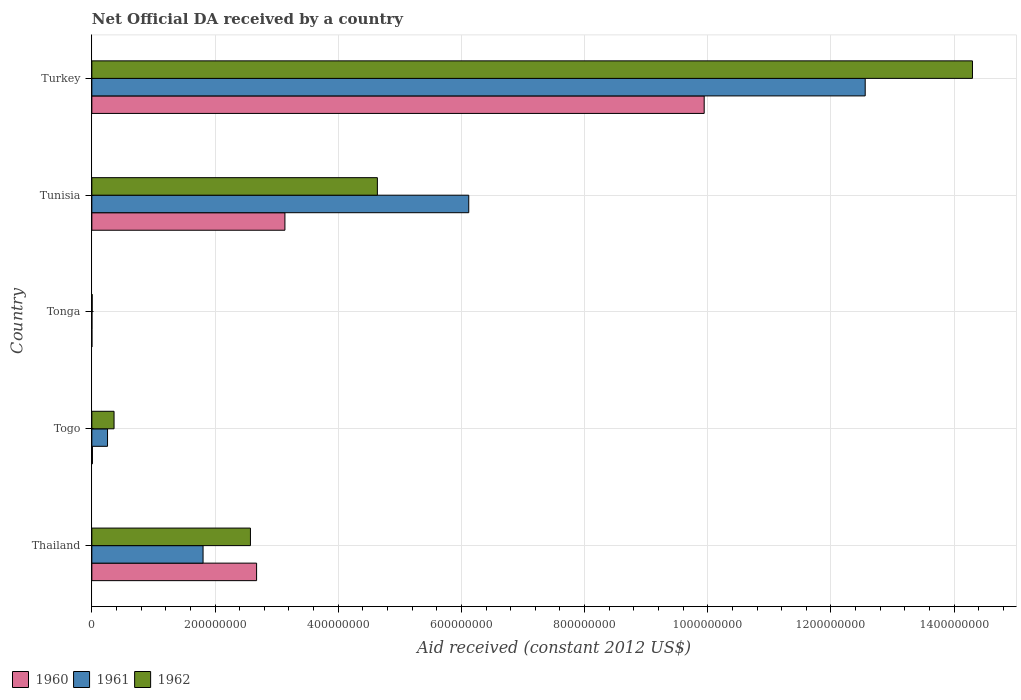How many different coloured bars are there?
Keep it short and to the point. 3. How many groups of bars are there?
Provide a succinct answer. 5. Are the number of bars on each tick of the Y-axis equal?
Make the answer very short. Yes. How many bars are there on the 1st tick from the top?
Provide a short and direct response. 3. How many bars are there on the 3rd tick from the bottom?
Give a very brief answer. 3. What is the label of the 2nd group of bars from the top?
Give a very brief answer. Tunisia. In how many cases, is the number of bars for a given country not equal to the number of legend labels?
Your answer should be compact. 0. Across all countries, what is the maximum net official development assistance aid received in 1961?
Offer a terse response. 1.26e+09. Across all countries, what is the minimum net official development assistance aid received in 1960?
Provide a succinct answer. 8.00e+04. In which country was the net official development assistance aid received in 1960 minimum?
Offer a terse response. Tonga. What is the total net official development assistance aid received in 1960 in the graph?
Your answer should be compact. 1.58e+09. What is the difference between the net official development assistance aid received in 1961 in Tonga and that in Tunisia?
Your answer should be very brief. -6.12e+08. What is the difference between the net official development assistance aid received in 1962 in Tunisia and the net official development assistance aid received in 1961 in Turkey?
Give a very brief answer. -7.92e+08. What is the average net official development assistance aid received in 1961 per country?
Keep it short and to the point. 4.15e+08. What is the difference between the net official development assistance aid received in 1962 and net official development assistance aid received in 1961 in Thailand?
Offer a terse response. 7.69e+07. In how many countries, is the net official development assistance aid received in 1961 greater than 440000000 US$?
Offer a terse response. 2. What is the ratio of the net official development assistance aid received in 1961 in Tonga to that in Turkey?
Keep it short and to the point. 0. What is the difference between the highest and the second highest net official development assistance aid received in 1962?
Ensure brevity in your answer.  9.66e+08. What is the difference between the highest and the lowest net official development assistance aid received in 1962?
Provide a short and direct response. 1.43e+09. In how many countries, is the net official development assistance aid received in 1962 greater than the average net official development assistance aid received in 1962 taken over all countries?
Ensure brevity in your answer.  2. Is the sum of the net official development assistance aid received in 1961 in Thailand and Togo greater than the maximum net official development assistance aid received in 1962 across all countries?
Your answer should be compact. No. What does the 1st bar from the top in Tunisia represents?
Your answer should be compact. 1962. Are all the bars in the graph horizontal?
Your answer should be compact. Yes. How many countries are there in the graph?
Your response must be concise. 5. What is the difference between two consecutive major ticks on the X-axis?
Offer a terse response. 2.00e+08. Are the values on the major ticks of X-axis written in scientific E-notation?
Keep it short and to the point. No. Does the graph contain any zero values?
Your answer should be compact. No. Does the graph contain grids?
Your answer should be very brief. Yes. Where does the legend appear in the graph?
Provide a short and direct response. Bottom left. How are the legend labels stacked?
Offer a very short reply. Horizontal. What is the title of the graph?
Ensure brevity in your answer.  Net Official DA received by a country. What is the label or title of the X-axis?
Keep it short and to the point. Aid received (constant 2012 US$). What is the label or title of the Y-axis?
Your answer should be very brief. Country. What is the Aid received (constant 2012 US$) in 1960 in Thailand?
Your answer should be compact. 2.67e+08. What is the Aid received (constant 2012 US$) in 1961 in Thailand?
Keep it short and to the point. 1.81e+08. What is the Aid received (constant 2012 US$) in 1962 in Thailand?
Provide a short and direct response. 2.57e+08. What is the Aid received (constant 2012 US$) of 1960 in Togo?
Your answer should be very brief. 9.70e+05. What is the Aid received (constant 2012 US$) in 1961 in Togo?
Your response must be concise. 2.55e+07. What is the Aid received (constant 2012 US$) in 1962 in Togo?
Your answer should be very brief. 3.60e+07. What is the Aid received (constant 2012 US$) in 1960 in Tonga?
Ensure brevity in your answer.  8.00e+04. What is the Aid received (constant 2012 US$) in 1961 in Tonga?
Offer a terse response. 1.60e+05. What is the Aid received (constant 2012 US$) of 1962 in Tonga?
Keep it short and to the point. 5.20e+05. What is the Aid received (constant 2012 US$) in 1960 in Tunisia?
Make the answer very short. 3.13e+08. What is the Aid received (constant 2012 US$) in 1961 in Tunisia?
Offer a very short reply. 6.12e+08. What is the Aid received (constant 2012 US$) in 1962 in Tunisia?
Provide a short and direct response. 4.64e+08. What is the Aid received (constant 2012 US$) in 1960 in Turkey?
Provide a short and direct response. 9.94e+08. What is the Aid received (constant 2012 US$) in 1961 in Turkey?
Offer a very short reply. 1.26e+09. What is the Aid received (constant 2012 US$) in 1962 in Turkey?
Make the answer very short. 1.43e+09. Across all countries, what is the maximum Aid received (constant 2012 US$) of 1960?
Your answer should be compact. 9.94e+08. Across all countries, what is the maximum Aid received (constant 2012 US$) in 1961?
Make the answer very short. 1.26e+09. Across all countries, what is the maximum Aid received (constant 2012 US$) of 1962?
Provide a succinct answer. 1.43e+09. Across all countries, what is the minimum Aid received (constant 2012 US$) of 1960?
Ensure brevity in your answer.  8.00e+04. Across all countries, what is the minimum Aid received (constant 2012 US$) in 1962?
Ensure brevity in your answer.  5.20e+05. What is the total Aid received (constant 2012 US$) in 1960 in the graph?
Provide a succinct answer. 1.58e+09. What is the total Aid received (constant 2012 US$) of 1961 in the graph?
Give a very brief answer. 2.07e+09. What is the total Aid received (constant 2012 US$) in 1962 in the graph?
Provide a short and direct response. 2.19e+09. What is the difference between the Aid received (constant 2012 US$) in 1960 in Thailand and that in Togo?
Your response must be concise. 2.67e+08. What is the difference between the Aid received (constant 2012 US$) of 1961 in Thailand and that in Togo?
Your answer should be compact. 1.55e+08. What is the difference between the Aid received (constant 2012 US$) in 1962 in Thailand and that in Togo?
Provide a succinct answer. 2.21e+08. What is the difference between the Aid received (constant 2012 US$) in 1960 in Thailand and that in Tonga?
Give a very brief answer. 2.67e+08. What is the difference between the Aid received (constant 2012 US$) of 1961 in Thailand and that in Tonga?
Your response must be concise. 1.80e+08. What is the difference between the Aid received (constant 2012 US$) of 1962 in Thailand and that in Tonga?
Make the answer very short. 2.57e+08. What is the difference between the Aid received (constant 2012 US$) in 1960 in Thailand and that in Tunisia?
Ensure brevity in your answer.  -4.60e+07. What is the difference between the Aid received (constant 2012 US$) in 1961 in Thailand and that in Tunisia?
Keep it short and to the point. -4.31e+08. What is the difference between the Aid received (constant 2012 US$) in 1962 in Thailand and that in Tunisia?
Offer a very short reply. -2.06e+08. What is the difference between the Aid received (constant 2012 US$) of 1960 in Thailand and that in Turkey?
Provide a short and direct response. -7.27e+08. What is the difference between the Aid received (constant 2012 US$) of 1961 in Thailand and that in Turkey?
Your answer should be very brief. -1.08e+09. What is the difference between the Aid received (constant 2012 US$) in 1962 in Thailand and that in Turkey?
Your answer should be very brief. -1.17e+09. What is the difference between the Aid received (constant 2012 US$) in 1960 in Togo and that in Tonga?
Offer a very short reply. 8.90e+05. What is the difference between the Aid received (constant 2012 US$) of 1961 in Togo and that in Tonga?
Provide a succinct answer. 2.53e+07. What is the difference between the Aid received (constant 2012 US$) of 1962 in Togo and that in Tonga?
Give a very brief answer. 3.55e+07. What is the difference between the Aid received (constant 2012 US$) in 1960 in Togo and that in Tunisia?
Give a very brief answer. -3.12e+08. What is the difference between the Aid received (constant 2012 US$) in 1961 in Togo and that in Tunisia?
Give a very brief answer. -5.86e+08. What is the difference between the Aid received (constant 2012 US$) of 1962 in Togo and that in Tunisia?
Offer a terse response. -4.28e+08. What is the difference between the Aid received (constant 2012 US$) in 1960 in Togo and that in Turkey?
Keep it short and to the point. -9.93e+08. What is the difference between the Aid received (constant 2012 US$) of 1961 in Togo and that in Turkey?
Offer a very short reply. -1.23e+09. What is the difference between the Aid received (constant 2012 US$) of 1962 in Togo and that in Turkey?
Your response must be concise. -1.39e+09. What is the difference between the Aid received (constant 2012 US$) in 1960 in Tonga and that in Tunisia?
Offer a very short reply. -3.13e+08. What is the difference between the Aid received (constant 2012 US$) in 1961 in Tonga and that in Tunisia?
Give a very brief answer. -6.12e+08. What is the difference between the Aid received (constant 2012 US$) of 1962 in Tonga and that in Tunisia?
Your answer should be compact. -4.63e+08. What is the difference between the Aid received (constant 2012 US$) in 1960 in Tonga and that in Turkey?
Your answer should be compact. -9.94e+08. What is the difference between the Aid received (constant 2012 US$) of 1961 in Tonga and that in Turkey?
Keep it short and to the point. -1.26e+09. What is the difference between the Aid received (constant 2012 US$) of 1962 in Tonga and that in Turkey?
Offer a terse response. -1.43e+09. What is the difference between the Aid received (constant 2012 US$) of 1960 in Tunisia and that in Turkey?
Your answer should be very brief. -6.81e+08. What is the difference between the Aid received (constant 2012 US$) in 1961 in Tunisia and that in Turkey?
Your response must be concise. -6.44e+08. What is the difference between the Aid received (constant 2012 US$) of 1962 in Tunisia and that in Turkey?
Provide a short and direct response. -9.66e+08. What is the difference between the Aid received (constant 2012 US$) in 1960 in Thailand and the Aid received (constant 2012 US$) in 1961 in Togo?
Offer a very short reply. 2.42e+08. What is the difference between the Aid received (constant 2012 US$) of 1960 in Thailand and the Aid received (constant 2012 US$) of 1962 in Togo?
Make the answer very short. 2.31e+08. What is the difference between the Aid received (constant 2012 US$) of 1961 in Thailand and the Aid received (constant 2012 US$) of 1962 in Togo?
Ensure brevity in your answer.  1.45e+08. What is the difference between the Aid received (constant 2012 US$) of 1960 in Thailand and the Aid received (constant 2012 US$) of 1961 in Tonga?
Keep it short and to the point. 2.67e+08. What is the difference between the Aid received (constant 2012 US$) of 1960 in Thailand and the Aid received (constant 2012 US$) of 1962 in Tonga?
Provide a short and direct response. 2.67e+08. What is the difference between the Aid received (constant 2012 US$) in 1961 in Thailand and the Aid received (constant 2012 US$) in 1962 in Tonga?
Your answer should be compact. 1.80e+08. What is the difference between the Aid received (constant 2012 US$) in 1960 in Thailand and the Aid received (constant 2012 US$) in 1961 in Tunisia?
Keep it short and to the point. -3.44e+08. What is the difference between the Aid received (constant 2012 US$) in 1960 in Thailand and the Aid received (constant 2012 US$) in 1962 in Tunisia?
Provide a short and direct response. -1.96e+08. What is the difference between the Aid received (constant 2012 US$) of 1961 in Thailand and the Aid received (constant 2012 US$) of 1962 in Tunisia?
Your answer should be very brief. -2.83e+08. What is the difference between the Aid received (constant 2012 US$) of 1960 in Thailand and the Aid received (constant 2012 US$) of 1961 in Turkey?
Make the answer very short. -9.88e+08. What is the difference between the Aid received (constant 2012 US$) in 1960 in Thailand and the Aid received (constant 2012 US$) in 1962 in Turkey?
Ensure brevity in your answer.  -1.16e+09. What is the difference between the Aid received (constant 2012 US$) of 1961 in Thailand and the Aid received (constant 2012 US$) of 1962 in Turkey?
Provide a short and direct response. -1.25e+09. What is the difference between the Aid received (constant 2012 US$) in 1960 in Togo and the Aid received (constant 2012 US$) in 1961 in Tonga?
Ensure brevity in your answer.  8.10e+05. What is the difference between the Aid received (constant 2012 US$) in 1961 in Togo and the Aid received (constant 2012 US$) in 1962 in Tonga?
Your answer should be compact. 2.50e+07. What is the difference between the Aid received (constant 2012 US$) of 1960 in Togo and the Aid received (constant 2012 US$) of 1961 in Tunisia?
Keep it short and to the point. -6.11e+08. What is the difference between the Aid received (constant 2012 US$) in 1960 in Togo and the Aid received (constant 2012 US$) in 1962 in Tunisia?
Offer a very short reply. -4.63e+08. What is the difference between the Aid received (constant 2012 US$) in 1961 in Togo and the Aid received (constant 2012 US$) in 1962 in Tunisia?
Give a very brief answer. -4.38e+08. What is the difference between the Aid received (constant 2012 US$) in 1960 in Togo and the Aid received (constant 2012 US$) in 1961 in Turkey?
Ensure brevity in your answer.  -1.25e+09. What is the difference between the Aid received (constant 2012 US$) of 1960 in Togo and the Aid received (constant 2012 US$) of 1962 in Turkey?
Make the answer very short. -1.43e+09. What is the difference between the Aid received (constant 2012 US$) in 1961 in Togo and the Aid received (constant 2012 US$) in 1962 in Turkey?
Keep it short and to the point. -1.40e+09. What is the difference between the Aid received (constant 2012 US$) of 1960 in Tonga and the Aid received (constant 2012 US$) of 1961 in Tunisia?
Give a very brief answer. -6.12e+08. What is the difference between the Aid received (constant 2012 US$) in 1960 in Tonga and the Aid received (constant 2012 US$) in 1962 in Tunisia?
Give a very brief answer. -4.63e+08. What is the difference between the Aid received (constant 2012 US$) in 1961 in Tonga and the Aid received (constant 2012 US$) in 1962 in Tunisia?
Provide a short and direct response. -4.63e+08. What is the difference between the Aid received (constant 2012 US$) in 1960 in Tonga and the Aid received (constant 2012 US$) in 1961 in Turkey?
Your answer should be very brief. -1.26e+09. What is the difference between the Aid received (constant 2012 US$) of 1960 in Tonga and the Aid received (constant 2012 US$) of 1962 in Turkey?
Give a very brief answer. -1.43e+09. What is the difference between the Aid received (constant 2012 US$) in 1961 in Tonga and the Aid received (constant 2012 US$) in 1962 in Turkey?
Offer a very short reply. -1.43e+09. What is the difference between the Aid received (constant 2012 US$) of 1960 in Tunisia and the Aid received (constant 2012 US$) of 1961 in Turkey?
Ensure brevity in your answer.  -9.42e+08. What is the difference between the Aid received (constant 2012 US$) of 1960 in Tunisia and the Aid received (constant 2012 US$) of 1962 in Turkey?
Offer a terse response. -1.12e+09. What is the difference between the Aid received (constant 2012 US$) of 1961 in Tunisia and the Aid received (constant 2012 US$) of 1962 in Turkey?
Your response must be concise. -8.18e+08. What is the average Aid received (constant 2012 US$) of 1960 per country?
Offer a terse response. 3.15e+08. What is the average Aid received (constant 2012 US$) of 1961 per country?
Keep it short and to the point. 4.15e+08. What is the average Aid received (constant 2012 US$) in 1962 per country?
Ensure brevity in your answer.  4.37e+08. What is the difference between the Aid received (constant 2012 US$) of 1960 and Aid received (constant 2012 US$) of 1961 in Thailand?
Provide a short and direct response. 8.69e+07. What is the difference between the Aid received (constant 2012 US$) in 1960 and Aid received (constant 2012 US$) in 1962 in Thailand?
Give a very brief answer. 9.99e+06. What is the difference between the Aid received (constant 2012 US$) of 1961 and Aid received (constant 2012 US$) of 1962 in Thailand?
Offer a very short reply. -7.69e+07. What is the difference between the Aid received (constant 2012 US$) of 1960 and Aid received (constant 2012 US$) of 1961 in Togo?
Provide a short and direct response. -2.45e+07. What is the difference between the Aid received (constant 2012 US$) in 1960 and Aid received (constant 2012 US$) in 1962 in Togo?
Your response must be concise. -3.51e+07. What is the difference between the Aid received (constant 2012 US$) of 1961 and Aid received (constant 2012 US$) of 1962 in Togo?
Make the answer very short. -1.06e+07. What is the difference between the Aid received (constant 2012 US$) in 1960 and Aid received (constant 2012 US$) in 1961 in Tonga?
Your answer should be compact. -8.00e+04. What is the difference between the Aid received (constant 2012 US$) of 1960 and Aid received (constant 2012 US$) of 1962 in Tonga?
Offer a very short reply. -4.40e+05. What is the difference between the Aid received (constant 2012 US$) of 1961 and Aid received (constant 2012 US$) of 1962 in Tonga?
Offer a very short reply. -3.60e+05. What is the difference between the Aid received (constant 2012 US$) in 1960 and Aid received (constant 2012 US$) in 1961 in Tunisia?
Give a very brief answer. -2.98e+08. What is the difference between the Aid received (constant 2012 US$) of 1960 and Aid received (constant 2012 US$) of 1962 in Tunisia?
Provide a succinct answer. -1.50e+08. What is the difference between the Aid received (constant 2012 US$) of 1961 and Aid received (constant 2012 US$) of 1962 in Tunisia?
Make the answer very short. 1.48e+08. What is the difference between the Aid received (constant 2012 US$) in 1960 and Aid received (constant 2012 US$) in 1961 in Turkey?
Your answer should be very brief. -2.61e+08. What is the difference between the Aid received (constant 2012 US$) in 1960 and Aid received (constant 2012 US$) in 1962 in Turkey?
Provide a succinct answer. -4.36e+08. What is the difference between the Aid received (constant 2012 US$) of 1961 and Aid received (constant 2012 US$) of 1962 in Turkey?
Give a very brief answer. -1.74e+08. What is the ratio of the Aid received (constant 2012 US$) of 1960 in Thailand to that in Togo?
Keep it short and to the point. 275.75. What is the ratio of the Aid received (constant 2012 US$) of 1961 in Thailand to that in Togo?
Provide a succinct answer. 7.09. What is the ratio of the Aid received (constant 2012 US$) of 1962 in Thailand to that in Togo?
Provide a succinct answer. 7.14. What is the ratio of the Aid received (constant 2012 US$) of 1960 in Thailand to that in Tonga?
Give a very brief answer. 3343.5. What is the ratio of the Aid received (constant 2012 US$) in 1961 in Thailand to that in Tonga?
Offer a very short reply. 1128.5. What is the ratio of the Aid received (constant 2012 US$) of 1962 in Thailand to that in Tonga?
Offer a terse response. 495.17. What is the ratio of the Aid received (constant 2012 US$) of 1960 in Thailand to that in Tunisia?
Provide a succinct answer. 0.85. What is the ratio of the Aid received (constant 2012 US$) of 1961 in Thailand to that in Tunisia?
Your response must be concise. 0.3. What is the ratio of the Aid received (constant 2012 US$) in 1962 in Thailand to that in Tunisia?
Your response must be concise. 0.56. What is the ratio of the Aid received (constant 2012 US$) of 1960 in Thailand to that in Turkey?
Your answer should be very brief. 0.27. What is the ratio of the Aid received (constant 2012 US$) in 1961 in Thailand to that in Turkey?
Offer a very short reply. 0.14. What is the ratio of the Aid received (constant 2012 US$) in 1962 in Thailand to that in Turkey?
Make the answer very short. 0.18. What is the ratio of the Aid received (constant 2012 US$) of 1960 in Togo to that in Tonga?
Offer a terse response. 12.12. What is the ratio of the Aid received (constant 2012 US$) in 1961 in Togo to that in Tonga?
Make the answer very short. 159.19. What is the ratio of the Aid received (constant 2012 US$) in 1962 in Togo to that in Tonga?
Ensure brevity in your answer.  69.33. What is the ratio of the Aid received (constant 2012 US$) of 1960 in Togo to that in Tunisia?
Your answer should be compact. 0. What is the ratio of the Aid received (constant 2012 US$) in 1961 in Togo to that in Tunisia?
Your response must be concise. 0.04. What is the ratio of the Aid received (constant 2012 US$) in 1962 in Togo to that in Tunisia?
Offer a very short reply. 0.08. What is the ratio of the Aid received (constant 2012 US$) of 1961 in Togo to that in Turkey?
Your answer should be compact. 0.02. What is the ratio of the Aid received (constant 2012 US$) of 1962 in Togo to that in Turkey?
Make the answer very short. 0.03. What is the ratio of the Aid received (constant 2012 US$) of 1962 in Tonga to that in Tunisia?
Make the answer very short. 0. What is the ratio of the Aid received (constant 2012 US$) of 1960 in Tonga to that in Turkey?
Keep it short and to the point. 0. What is the ratio of the Aid received (constant 2012 US$) in 1960 in Tunisia to that in Turkey?
Your response must be concise. 0.32. What is the ratio of the Aid received (constant 2012 US$) of 1961 in Tunisia to that in Turkey?
Your response must be concise. 0.49. What is the ratio of the Aid received (constant 2012 US$) in 1962 in Tunisia to that in Turkey?
Make the answer very short. 0.32. What is the difference between the highest and the second highest Aid received (constant 2012 US$) in 1960?
Your answer should be very brief. 6.81e+08. What is the difference between the highest and the second highest Aid received (constant 2012 US$) of 1961?
Keep it short and to the point. 6.44e+08. What is the difference between the highest and the second highest Aid received (constant 2012 US$) of 1962?
Your answer should be very brief. 9.66e+08. What is the difference between the highest and the lowest Aid received (constant 2012 US$) in 1960?
Ensure brevity in your answer.  9.94e+08. What is the difference between the highest and the lowest Aid received (constant 2012 US$) of 1961?
Give a very brief answer. 1.26e+09. What is the difference between the highest and the lowest Aid received (constant 2012 US$) of 1962?
Offer a terse response. 1.43e+09. 